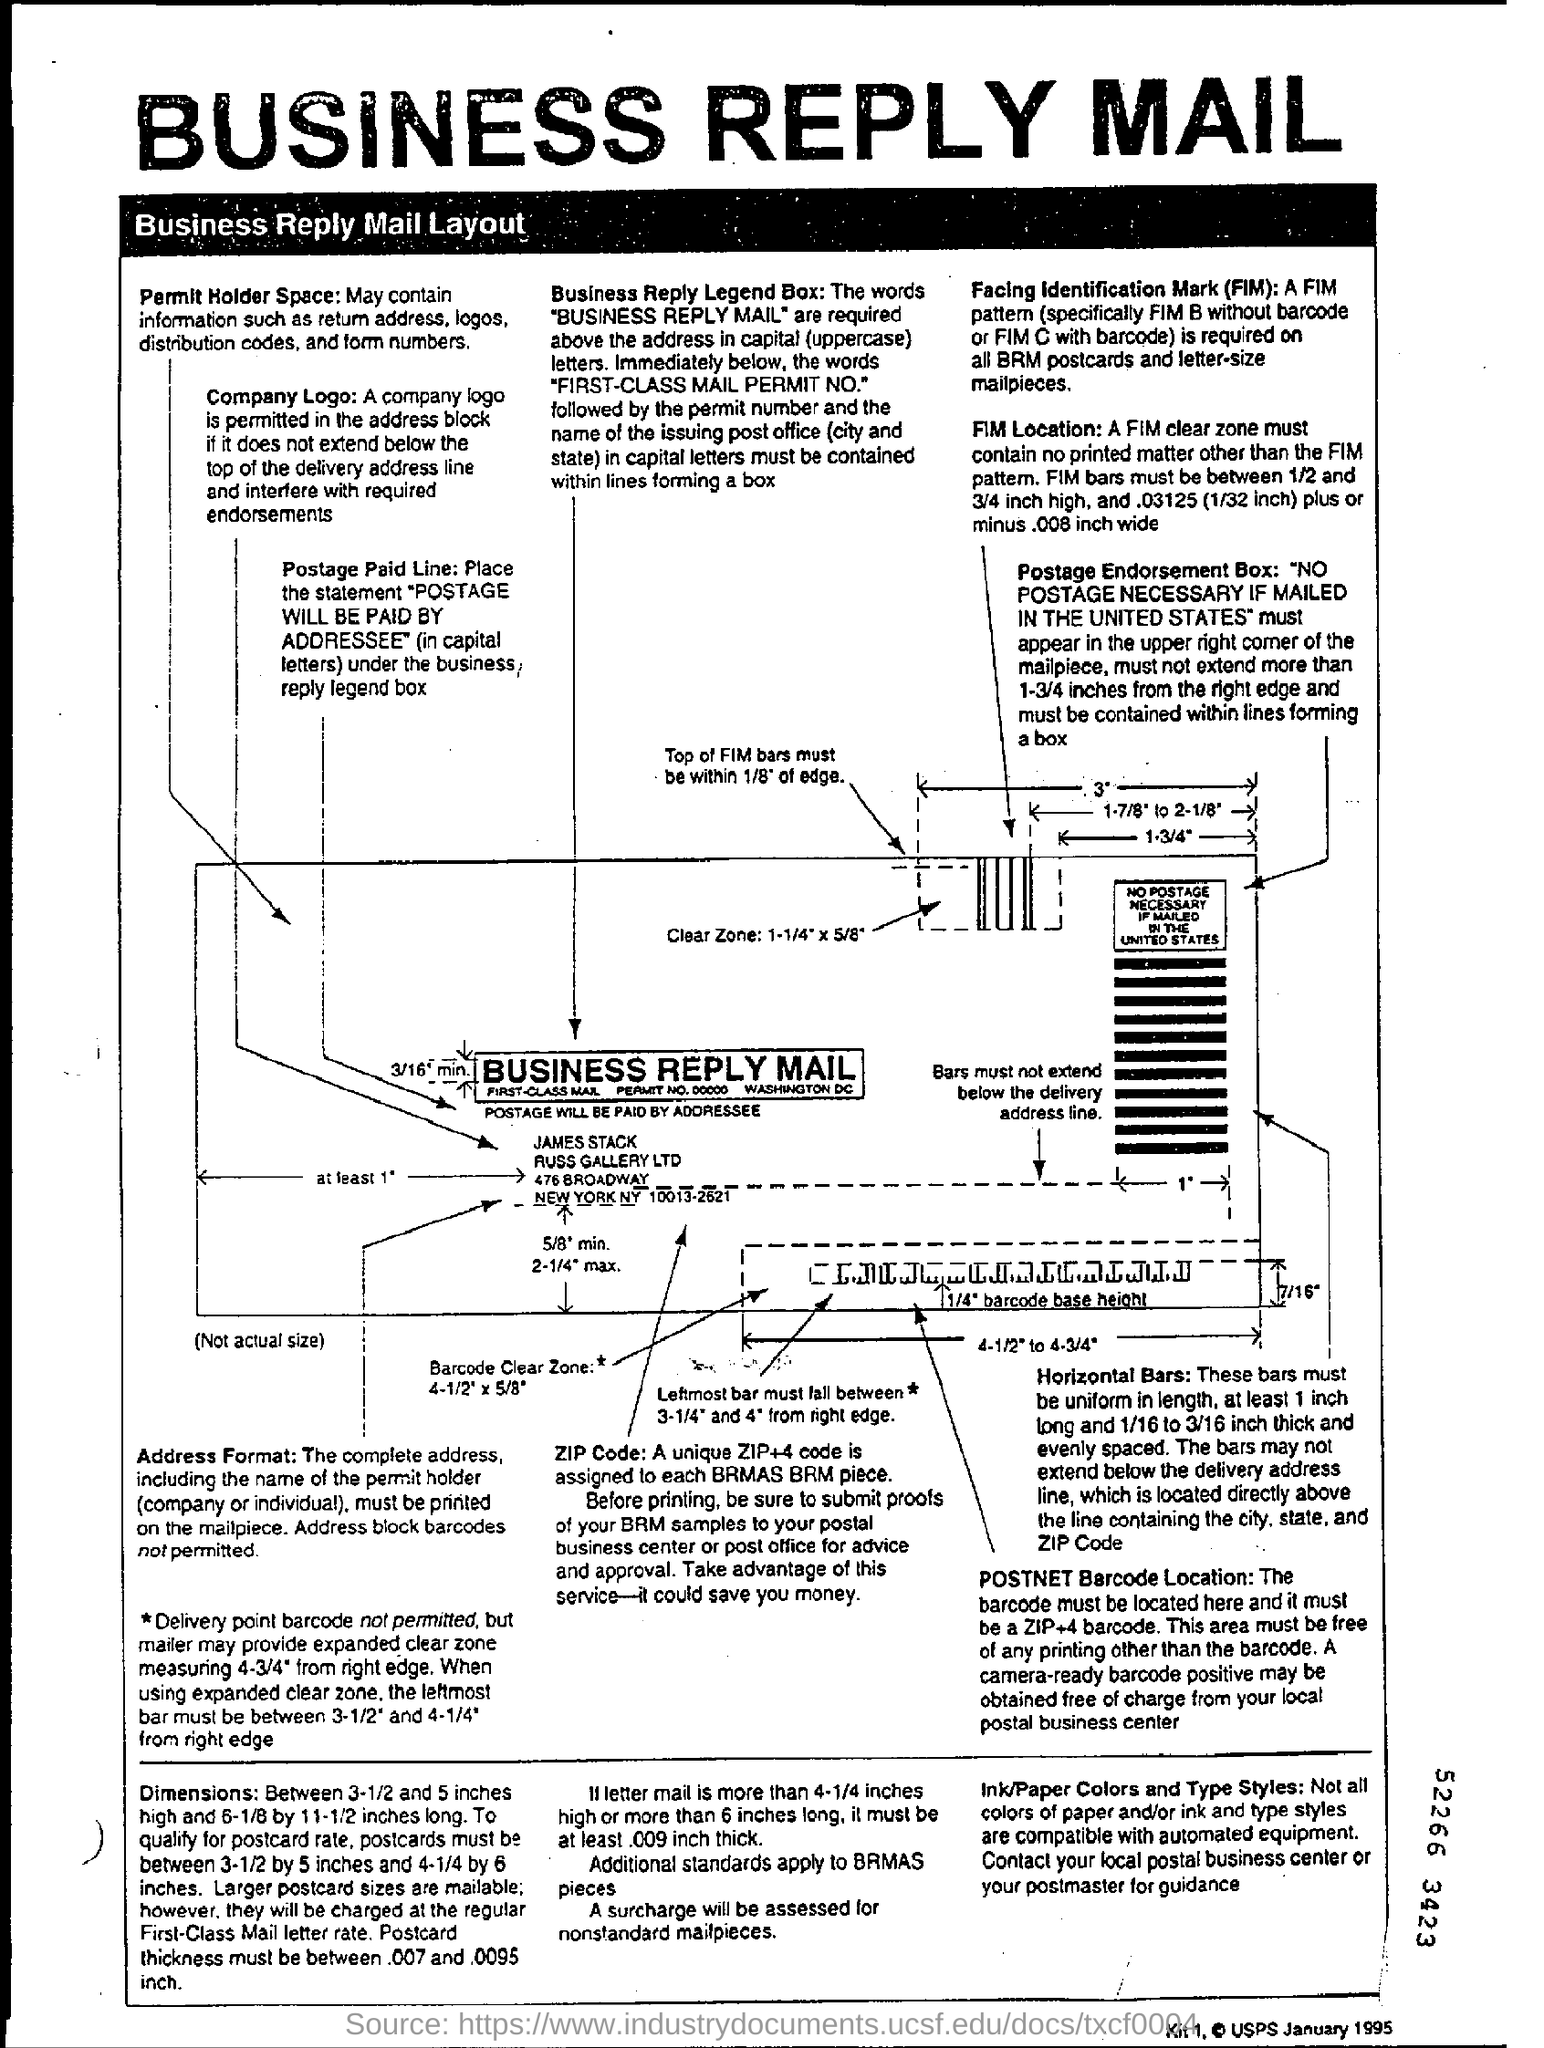What is the heading of the page at top?
Your answer should be very brief. Business reply mail. 